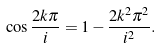<formula> <loc_0><loc_0><loc_500><loc_500>\cos \frac { 2 k \pi } { i } = 1 - \frac { 2 k ^ { 2 } \pi ^ { 2 } } { { i } ^ { 2 } } .</formula> 